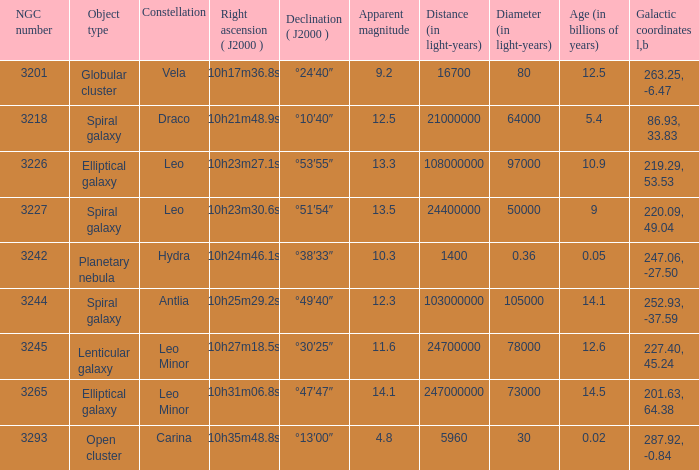What is the Apparent magnitude of a globular cluster? 9.2. 